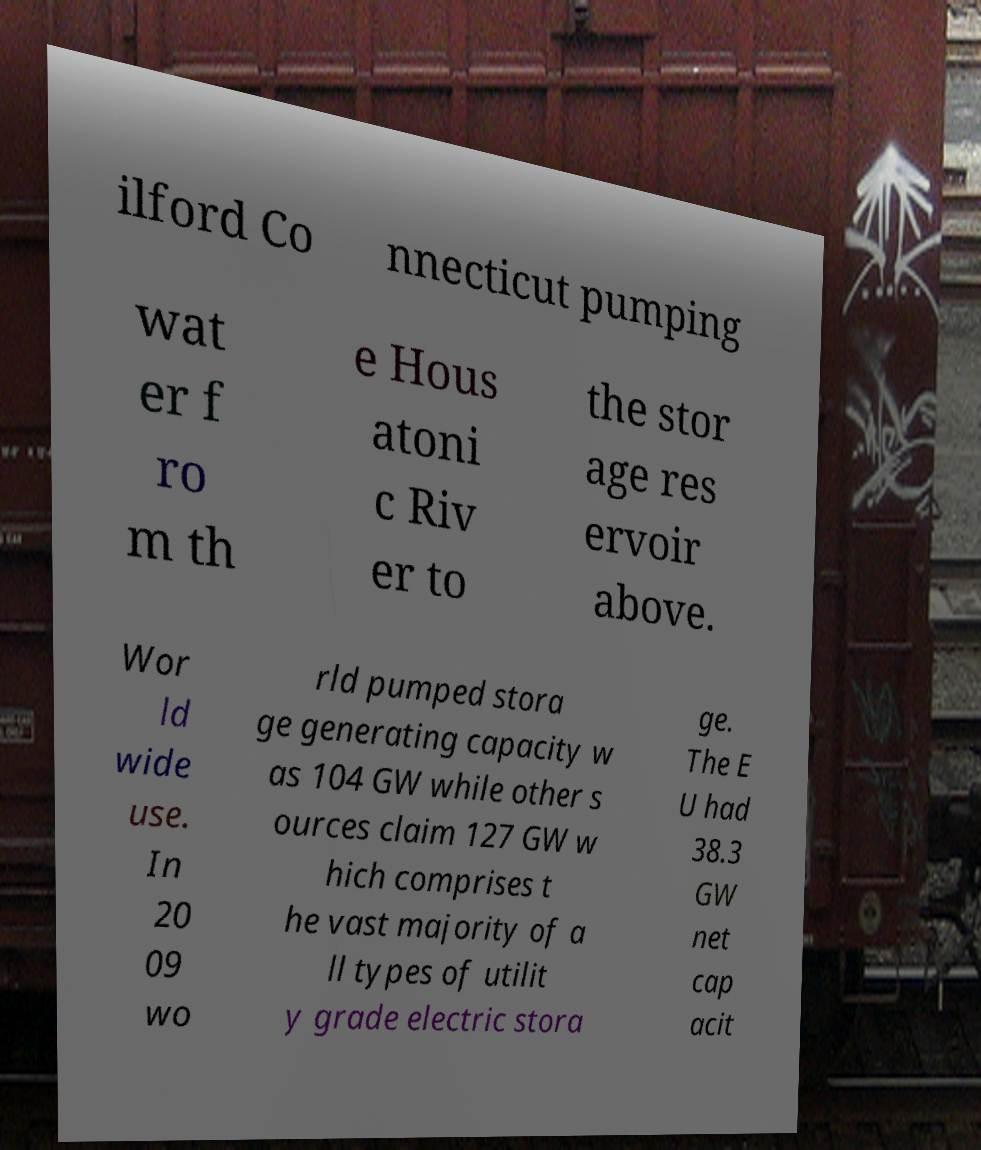Please read and relay the text visible in this image. What does it say? ilford Co nnecticut pumping wat er f ro m th e Hous atoni c Riv er to the stor age res ervoir above. Wor ld wide use. In 20 09 wo rld pumped stora ge generating capacity w as 104 GW while other s ources claim 127 GW w hich comprises t he vast majority of a ll types of utilit y grade electric stora ge. The E U had 38.3 GW net cap acit 